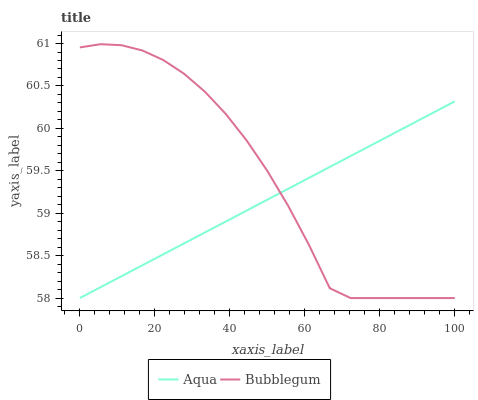Does Aqua have the minimum area under the curve?
Answer yes or no. Yes. Does Bubblegum have the maximum area under the curve?
Answer yes or no. Yes. Does Bubblegum have the minimum area under the curve?
Answer yes or no. No. Is Aqua the smoothest?
Answer yes or no. Yes. Is Bubblegum the roughest?
Answer yes or no. Yes. Is Bubblegum the smoothest?
Answer yes or no. No. Does Aqua have the lowest value?
Answer yes or no. Yes. Does Bubblegum have the highest value?
Answer yes or no. Yes. Does Aqua intersect Bubblegum?
Answer yes or no. Yes. Is Aqua less than Bubblegum?
Answer yes or no. No. Is Aqua greater than Bubblegum?
Answer yes or no. No. 